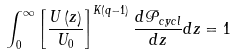<formula> <loc_0><loc_0><loc_500><loc_500>\int _ { 0 } ^ { \infty } \left [ \frac { U \left ( z \right ) } { U _ { 0 } } \right ] ^ { K \left ( q - 1 \right ) } \frac { d \mathcal { P } _ { c y c l } } { d z } d z = 1</formula> 